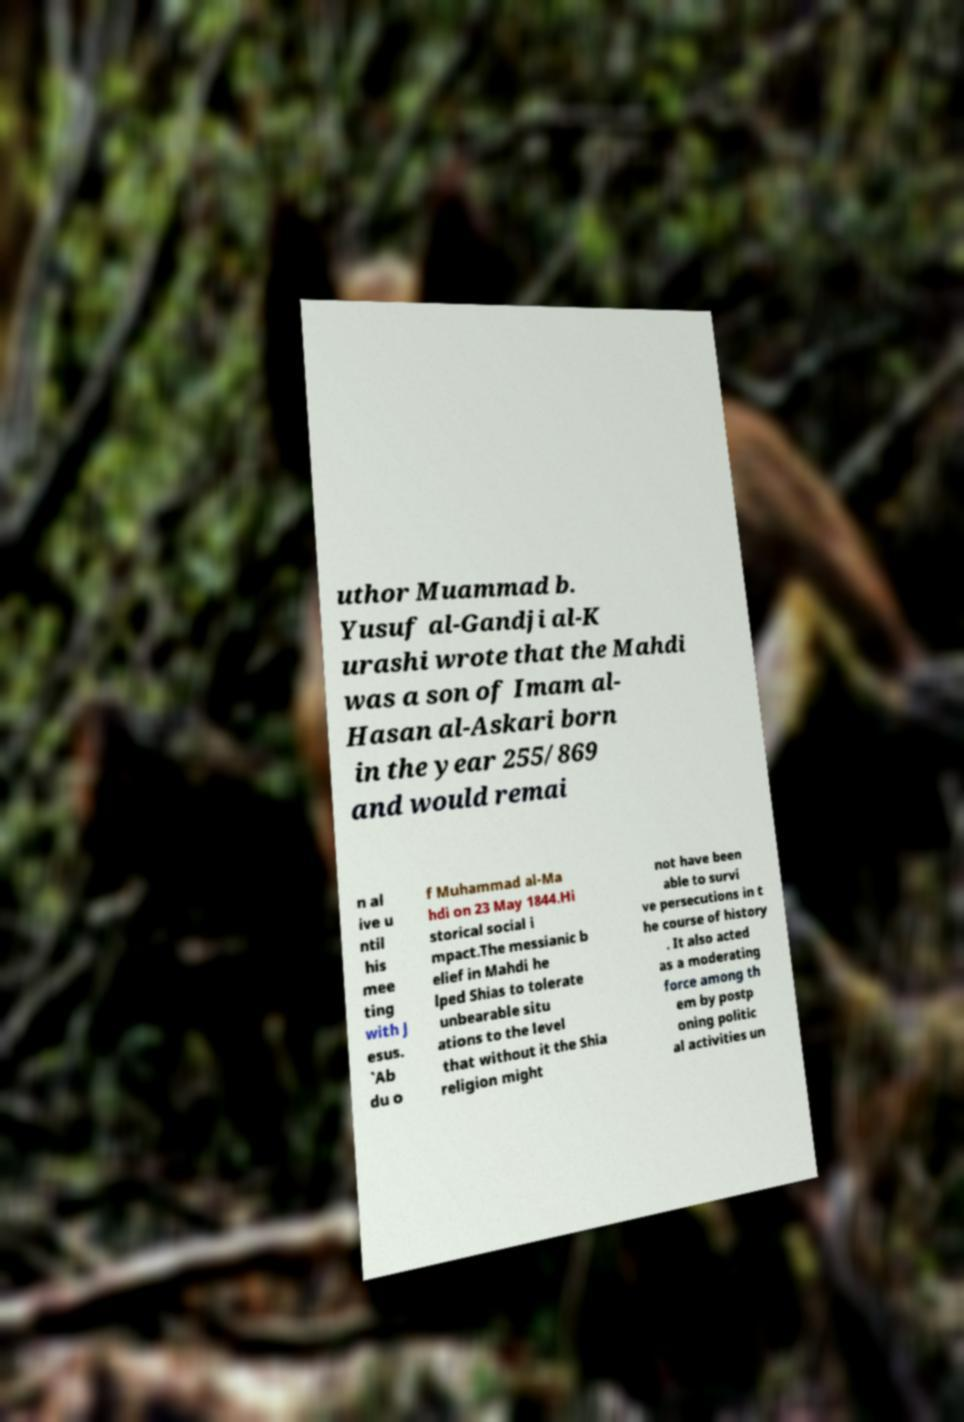Please read and relay the text visible in this image. What does it say? uthor Muammad b. Yusuf al-Gandji al-K urashi wrote that the Mahdi was a son of Imam al- Hasan al-Askari born in the year 255/869 and would remai n al ive u ntil his mee ting with J esus. `Ab du o f Muhammad al-Ma hdi on 23 May 1844.Hi storical social i mpact.The messianic b elief in Mahdi he lped Shias to tolerate unbearable situ ations to the level that without it the Shia religion might not have been able to survi ve persecutions in t he course of history . It also acted as a moderating force among th em by postp oning politic al activities un 